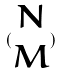<formula> <loc_0><loc_0><loc_500><loc_500>( \begin{matrix} N \\ M \end{matrix} )</formula> 